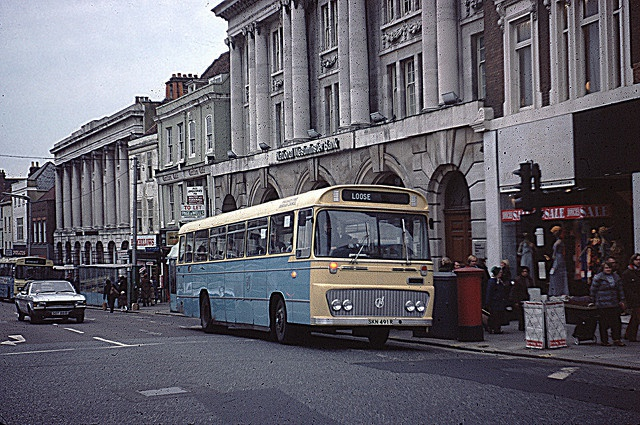Describe the objects in this image and their specific colors. I can see bus in lavender, gray, black, and darkgray tones, car in lavender, black, white, gray, and darkgray tones, people in lavender, black, and gray tones, bus in lavender, black, gray, navy, and darkgray tones, and traffic light in lavender, black, gray, and darkgray tones in this image. 